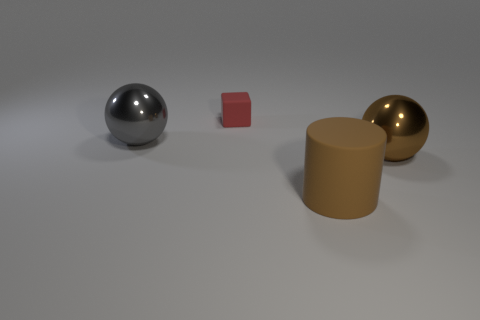How many large matte objects are the same shape as the gray shiny thing?
Offer a very short reply. 0. Is the material of the gray thing that is in front of the small matte block the same as the tiny block?
Offer a terse response. No. How many blocks are tiny rubber objects or brown matte things?
Your response must be concise. 1. What shape is the rubber thing in front of the matte object that is behind the big object to the left of the cylinder?
Provide a succinct answer. Cylinder. What shape is the shiny object that is the same color as the large rubber thing?
Offer a very short reply. Sphere. How many brown cylinders are the same size as the brown metallic thing?
Keep it short and to the point. 1. There is a shiny object behind the large brown metallic thing; are there any big gray things that are on the left side of it?
Provide a succinct answer. No. How many things are either big brown cylinders or large brown metal objects?
Provide a short and direct response. 2. There is a large metallic ball that is right of the matte object that is in front of the metal object behind the big brown metal thing; what is its color?
Your response must be concise. Brown. Is there any other thing that is the same color as the small matte object?
Your answer should be very brief. No. 